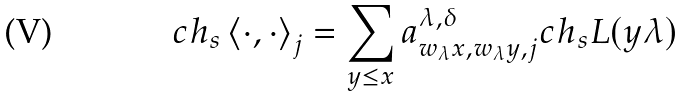<formula> <loc_0><loc_0><loc_500><loc_500>c h _ { s } \left < \cdot , \cdot \right > _ { j } = \sum _ { y \leq x } a ^ { \lambda , \delta } _ { w _ { \lambda } x , w _ { \lambda } y , j } c h _ { s } L ( y \lambda )</formula> 